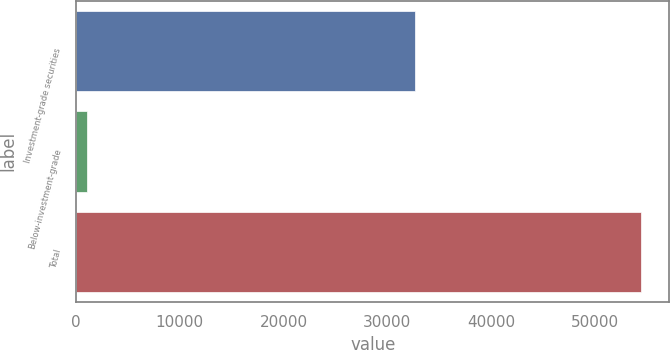<chart> <loc_0><loc_0><loc_500><loc_500><bar_chart><fcel>Investment-grade securities<fcel>Below-investment-grade<fcel>Total<nl><fcel>32639<fcel>1032<fcel>54475<nl></chart> 